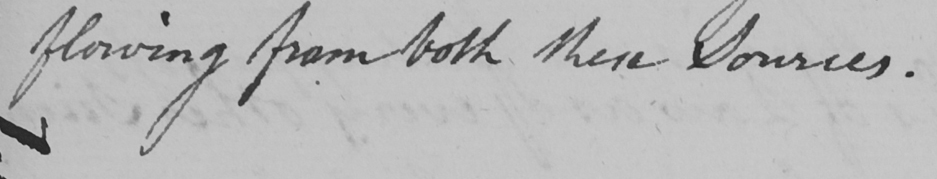Can you read and transcribe this handwriting? flowing from both these sources . 